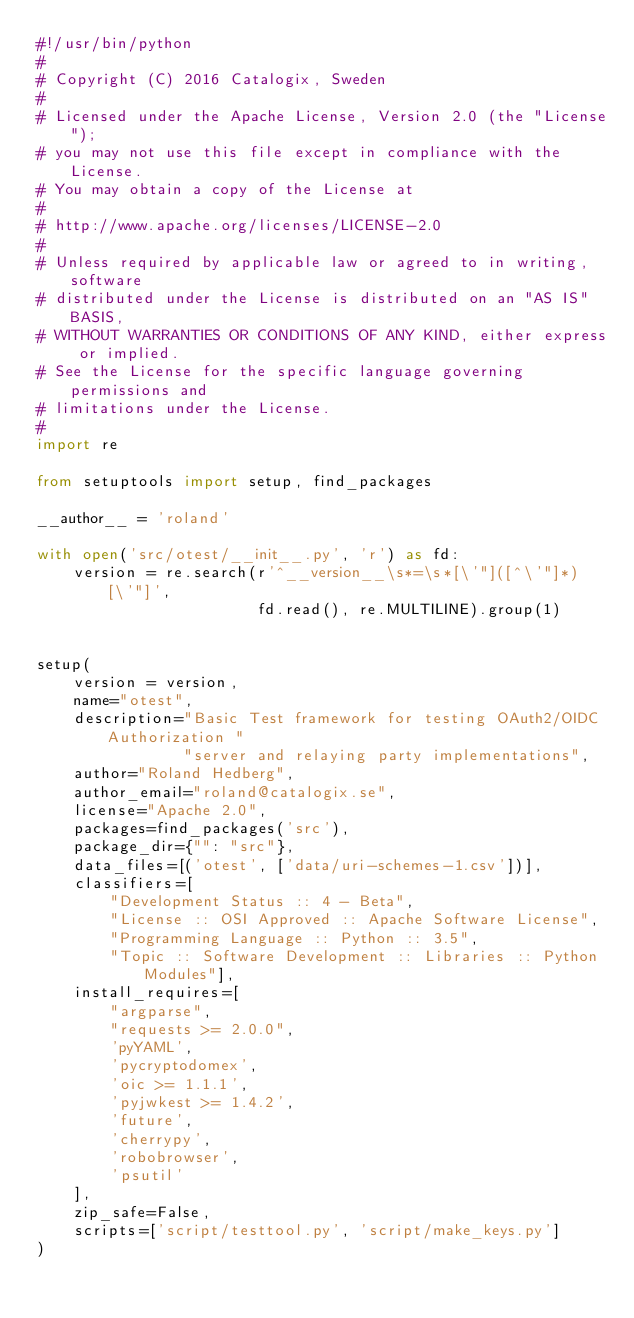Convert code to text. <code><loc_0><loc_0><loc_500><loc_500><_Python_>#!/usr/bin/python
#
# Copyright (C) 2016 Catalogix, Sweden
#
# Licensed under the Apache License, Version 2.0 (the "License");
# you may not use this file except in compliance with the License.
# You may obtain a copy of the License at
#
# http://www.apache.org/licenses/LICENSE-2.0
#
# Unless required by applicable law or agreed to in writing, software
# distributed under the License is distributed on an "AS IS" BASIS,
# WITHOUT WARRANTIES OR CONDITIONS OF ANY KIND, either express or implied.
# See the License for the specific language governing permissions and
# limitations under the License.
#
import re

from setuptools import setup, find_packages

__author__ = 'roland'

with open('src/otest/__init__.py', 'r') as fd:
    version = re.search(r'^__version__\s*=\s*[\'"]([^\'"]*)[\'"]',
                        fd.read(), re.MULTILINE).group(1)


setup(
    version = version,
    name="otest",
    description="Basic Test framework for testing OAuth2/OIDC Authorization "
                "server and relaying party implementations",
    author="Roland Hedberg",
    author_email="roland@catalogix.se",
    license="Apache 2.0",
    packages=find_packages('src'),
    package_dir={"": "src"},
    data_files=[('otest', ['data/uri-schemes-1.csv'])],
    classifiers=[
        "Development Status :: 4 - Beta",
        "License :: OSI Approved :: Apache Software License",
        "Programming Language :: Python :: 3.5",
        "Topic :: Software Development :: Libraries :: Python Modules"],
    install_requires=[
        "argparse",
        "requests >= 2.0.0",
        'pyYAML',
        'pycryptodomex',
        'oic >= 1.1.1',
        'pyjwkest >= 1.4.2',
        'future',
        'cherrypy',
        'robobrowser',
        'psutil'
    ],
    zip_safe=False,
    scripts=['script/testtool.py', 'script/make_keys.py']
)
</code> 